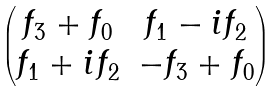Convert formula to latex. <formula><loc_0><loc_0><loc_500><loc_500>\begin{pmatrix} f _ { 3 } + f _ { 0 } & f _ { 1 } - i f _ { 2 } \\ f _ { 1 } + i f _ { 2 } & - f _ { 3 } + f _ { 0 } \end{pmatrix}</formula> 